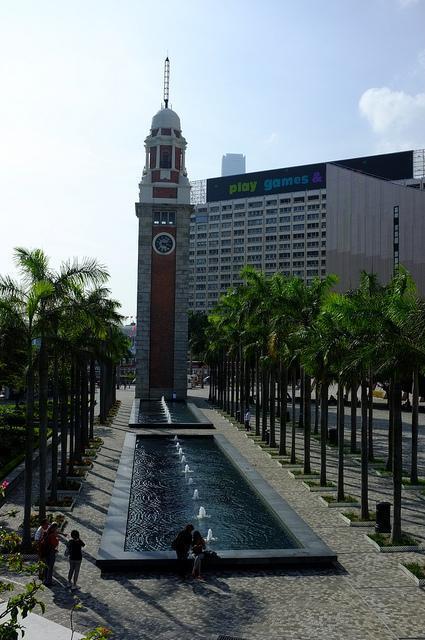How many horses are there?
Give a very brief answer. 0. 